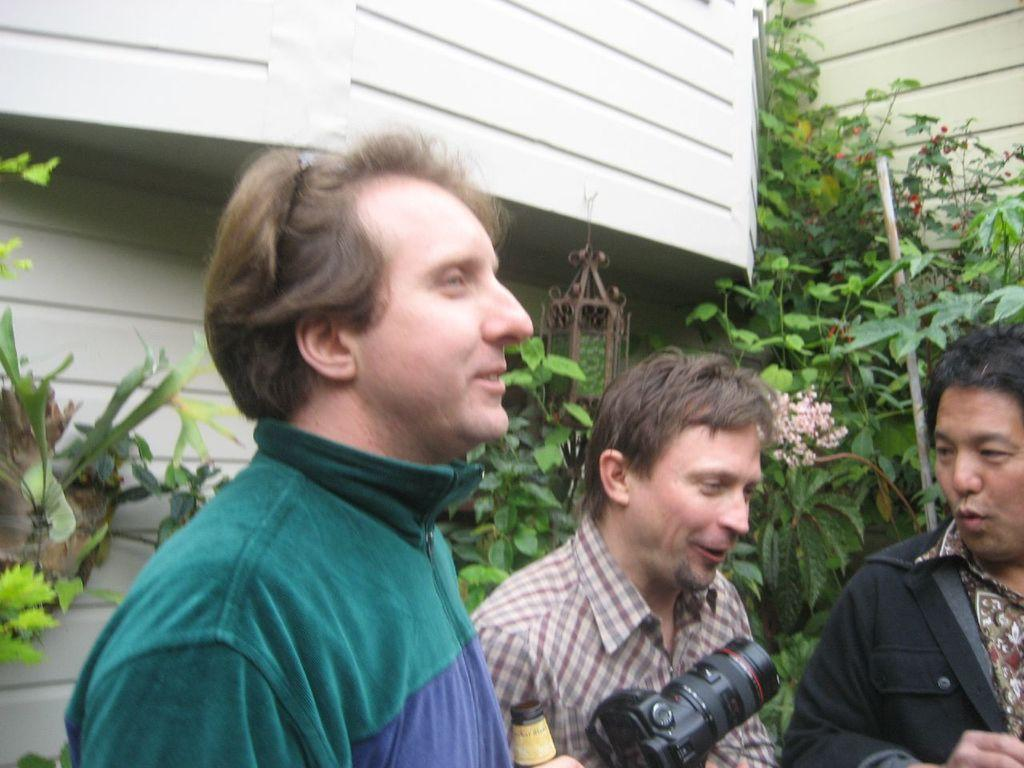How many people are in the image? There are three persons in the image. What are the people holding in the image? One person is holding a bottle, and another person is holding a camera. What can be seen in the background of the image? There are plants, flowers, and a wall in the background of the image. What type of hen can be seen in the image? There is no hen present in the image. What stage of development is the arithmetic at in the image? There is no arithmetic or developmental stage depicted in the image. 